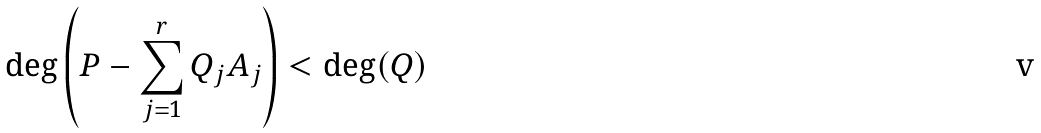<formula> <loc_0><loc_0><loc_500><loc_500>\deg \left ( P - \sum _ { j = 1 } ^ { r } Q _ { j } A _ { j } \right ) < \deg ( Q )</formula> 